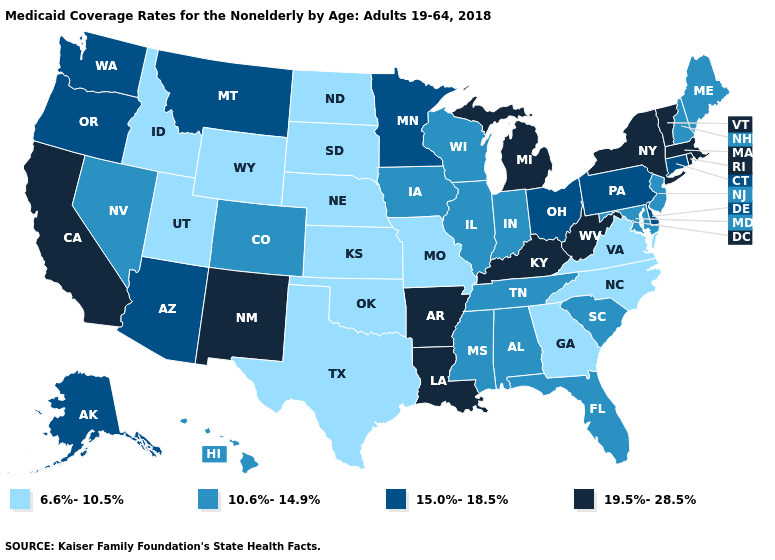Name the states that have a value in the range 19.5%-28.5%?
Concise answer only. Arkansas, California, Kentucky, Louisiana, Massachusetts, Michigan, New Mexico, New York, Rhode Island, Vermont, West Virginia. Which states have the highest value in the USA?
Concise answer only. Arkansas, California, Kentucky, Louisiana, Massachusetts, Michigan, New Mexico, New York, Rhode Island, Vermont, West Virginia. Among the states that border Wisconsin , does Iowa have the highest value?
Quick response, please. No. Which states have the highest value in the USA?
Keep it brief. Arkansas, California, Kentucky, Louisiana, Massachusetts, Michigan, New Mexico, New York, Rhode Island, Vermont, West Virginia. What is the value of Illinois?
Keep it brief. 10.6%-14.9%. Which states have the highest value in the USA?
Short answer required. Arkansas, California, Kentucky, Louisiana, Massachusetts, Michigan, New Mexico, New York, Rhode Island, Vermont, West Virginia. Which states have the highest value in the USA?
Answer briefly. Arkansas, California, Kentucky, Louisiana, Massachusetts, Michigan, New Mexico, New York, Rhode Island, Vermont, West Virginia. Among the states that border Mississippi , does Arkansas have the highest value?
Answer briefly. Yes. Which states have the lowest value in the West?
Write a very short answer. Idaho, Utah, Wyoming. What is the lowest value in the USA?
Quick response, please. 6.6%-10.5%. Is the legend a continuous bar?
Be succinct. No. Name the states that have a value in the range 19.5%-28.5%?
Concise answer only. Arkansas, California, Kentucky, Louisiana, Massachusetts, Michigan, New Mexico, New York, Rhode Island, Vermont, West Virginia. Among the states that border Missouri , does Kansas have the highest value?
Concise answer only. No. What is the lowest value in states that border New Jersey?
Keep it brief. 15.0%-18.5%. Name the states that have a value in the range 10.6%-14.9%?
Concise answer only. Alabama, Colorado, Florida, Hawaii, Illinois, Indiana, Iowa, Maine, Maryland, Mississippi, Nevada, New Hampshire, New Jersey, South Carolina, Tennessee, Wisconsin. 